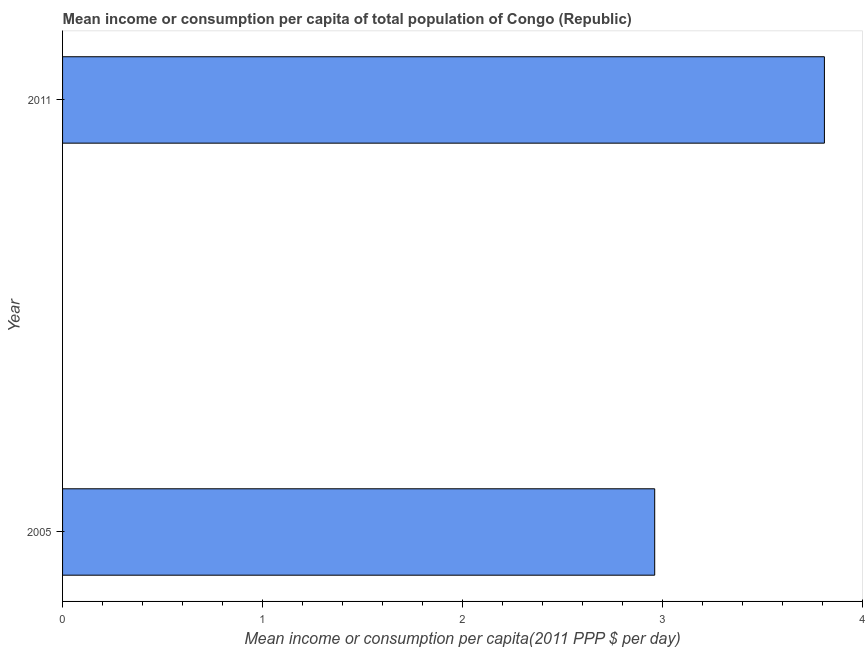What is the title of the graph?
Offer a terse response. Mean income or consumption per capita of total population of Congo (Republic). What is the label or title of the X-axis?
Your answer should be very brief. Mean income or consumption per capita(2011 PPP $ per day). What is the label or title of the Y-axis?
Provide a succinct answer. Year. What is the mean income or consumption in 2011?
Make the answer very short. 3.81. Across all years, what is the maximum mean income or consumption?
Give a very brief answer. 3.81. Across all years, what is the minimum mean income or consumption?
Offer a terse response. 2.96. What is the sum of the mean income or consumption?
Provide a succinct answer. 6.77. What is the difference between the mean income or consumption in 2005 and 2011?
Keep it short and to the point. -0.85. What is the average mean income or consumption per year?
Make the answer very short. 3.39. What is the median mean income or consumption?
Keep it short and to the point. 3.39. What is the ratio of the mean income or consumption in 2005 to that in 2011?
Make the answer very short. 0.78. Is the mean income or consumption in 2005 less than that in 2011?
Provide a short and direct response. Yes. Are all the bars in the graph horizontal?
Your answer should be compact. Yes. How many years are there in the graph?
Your response must be concise. 2. What is the difference between two consecutive major ticks on the X-axis?
Keep it short and to the point. 1. What is the Mean income or consumption per capita(2011 PPP $ per day) in 2005?
Your answer should be very brief. 2.96. What is the Mean income or consumption per capita(2011 PPP $ per day) in 2011?
Ensure brevity in your answer.  3.81. What is the difference between the Mean income or consumption per capita(2011 PPP $ per day) in 2005 and 2011?
Ensure brevity in your answer.  -0.85. What is the ratio of the Mean income or consumption per capita(2011 PPP $ per day) in 2005 to that in 2011?
Your answer should be very brief. 0.78. 